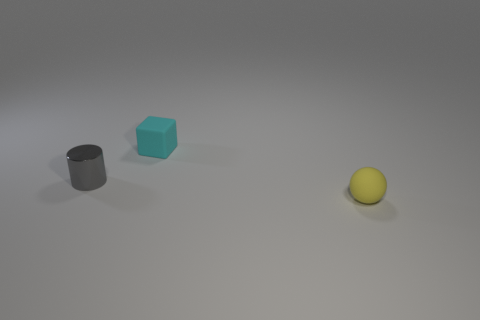Are there any other things that have the same material as the small gray object?
Provide a short and direct response. No. Are there the same number of matte spheres behind the tiny block and rubber blocks to the left of the gray metal thing?
Offer a very short reply. Yes. Is there a yellow rubber sphere behind the tiny thing that is on the left side of the rubber object that is left of the yellow matte thing?
Your answer should be very brief. No. Are there more small matte things to the left of the yellow sphere than large blue rubber balls?
Provide a succinct answer. Yes. How many things are yellow rubber objects or purple shiny balls?
Provide a short and direct response. 1. The tiny shiny cylinder has what color?
Ensure brevity in your answer.  Gray. Are there any metallic things behind the small cyan rubber thing?
Your answer should be very brief. No. What color is the tiny rubber object that is to the right of the tiny cyan rubber thing behind the small object to the left of the cube?
Keep it short and to the point. Yellow. How many tiny things are to the left of the cyan rubber cube and on the right side of the metallic cylinder?
Your response must be concise. 0. How many blocks are yellow things or tiny objects?
Make the answer very short. 1. 